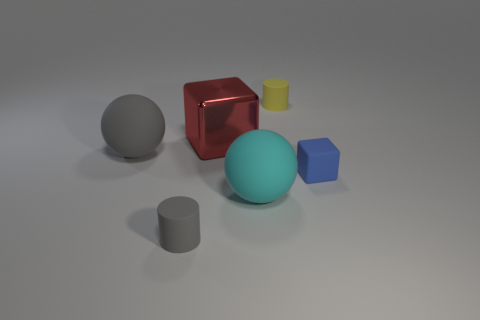There is a blue object that is the same size as the yellow cylinder; what is it made of? The blue object, which appears to be the same size as the yellow cylinder in the image, resembles a blue rubber bouncy ball commonly found in children's toy collections. 